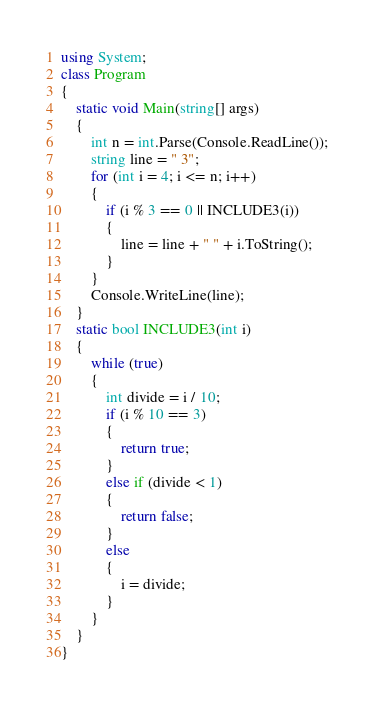<code> <loc_0><loc_0><loc_500><loc_500><_C#_>using System;
class Program
{
    static void Main(string[] args)
    {
        int n = int.Parse(Console.ReadLine());
        string line = " 3";
        for (int i = 4; i <= n; i++)
        {
            if (i % 3 == 0 || INCLUDE3(i))
            {
                line = line + " " + i.ToString();
            }
        }
        Console.WriteLine(line);
    }
    static bool INCLUDE3(int i)
    {
        while (true)
        {
            int divide = i / 10;
            if (i % 10 == 3)
            {
                return true;
            }
            else if (divide < 1)
            {
                return false;
            }
            else
            {
                i = divide;
            }
        }        
    }
}</code> 